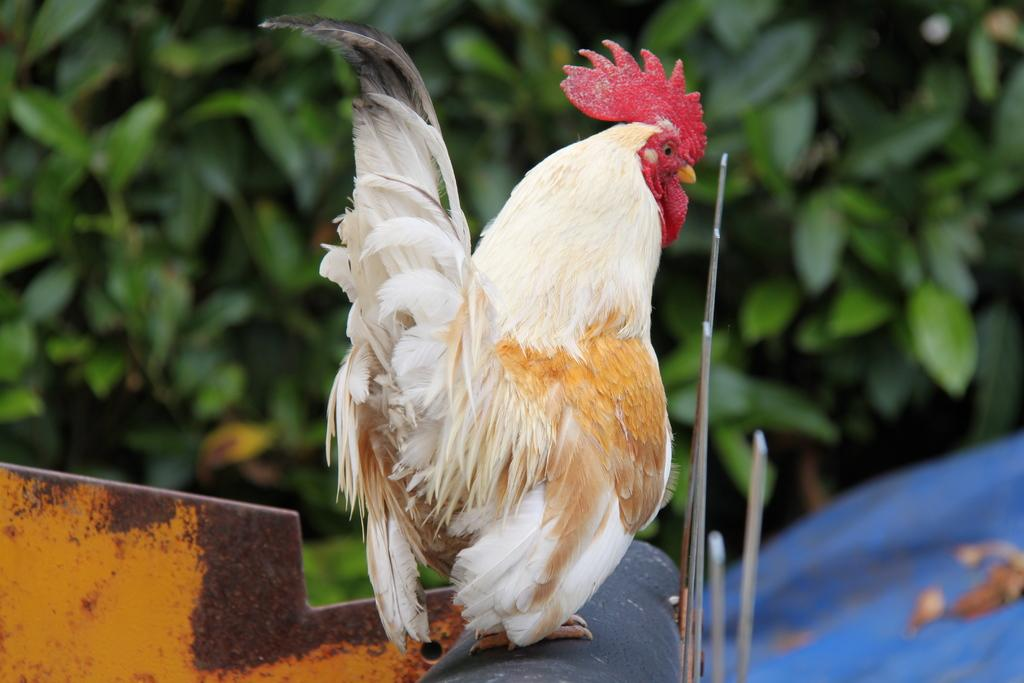What animal is in the center of the image? There is a hen in the center of the image. What object can be seen at the bottom of the image? There is a rod at the bottom of the image. What type of natural scenery is visible in the background of the image? There are trees in the background of the image. How many spiders are crawling on the hen in the image? There are no spiders visible on the hen in the image. What type of locket can be seen hanging from the hen's neck in the image? There is no locket present on the hen in the image. 